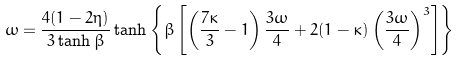<formula> <loc_0><loc_0><loc_500><loc_500>\omega = \frac { 4 ( 1 - 2 \eta ) } { 3 \tanh { \beta } } \tanh \left \{ \beta \left [ \left ( \frac { 7 \kappa } { 3 } - 1 \right ) \frac { 3 \omega } { 4 } + 2 ( 1 - \kappa ) \left ( \frac { 3 \omega } { 4 } \right ) ^ { 3 } \right ] \right \} \\</formula> 